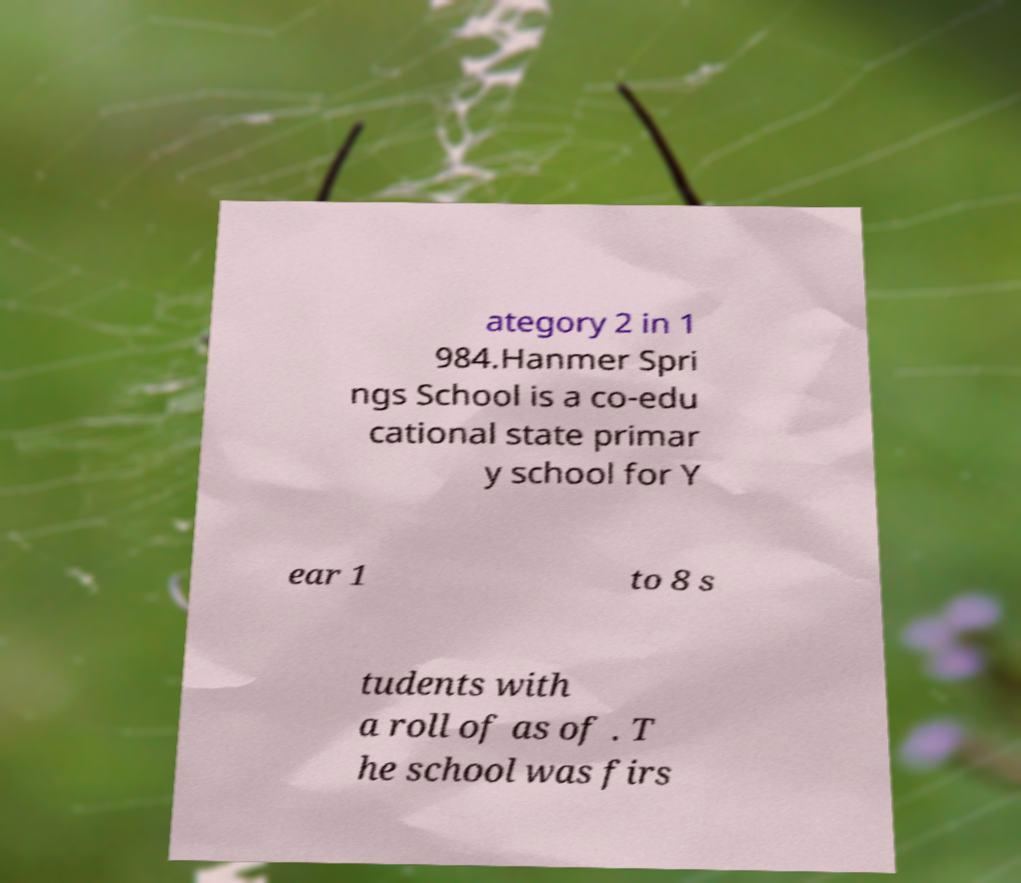Could you extract and type out the text from this image? ategory 2 in 1 984.Hanmer Spri ngs School is a co-edu cational state primar y school for Y ear 1 to 8 s tudents with a roll of as of . T he school was firs 